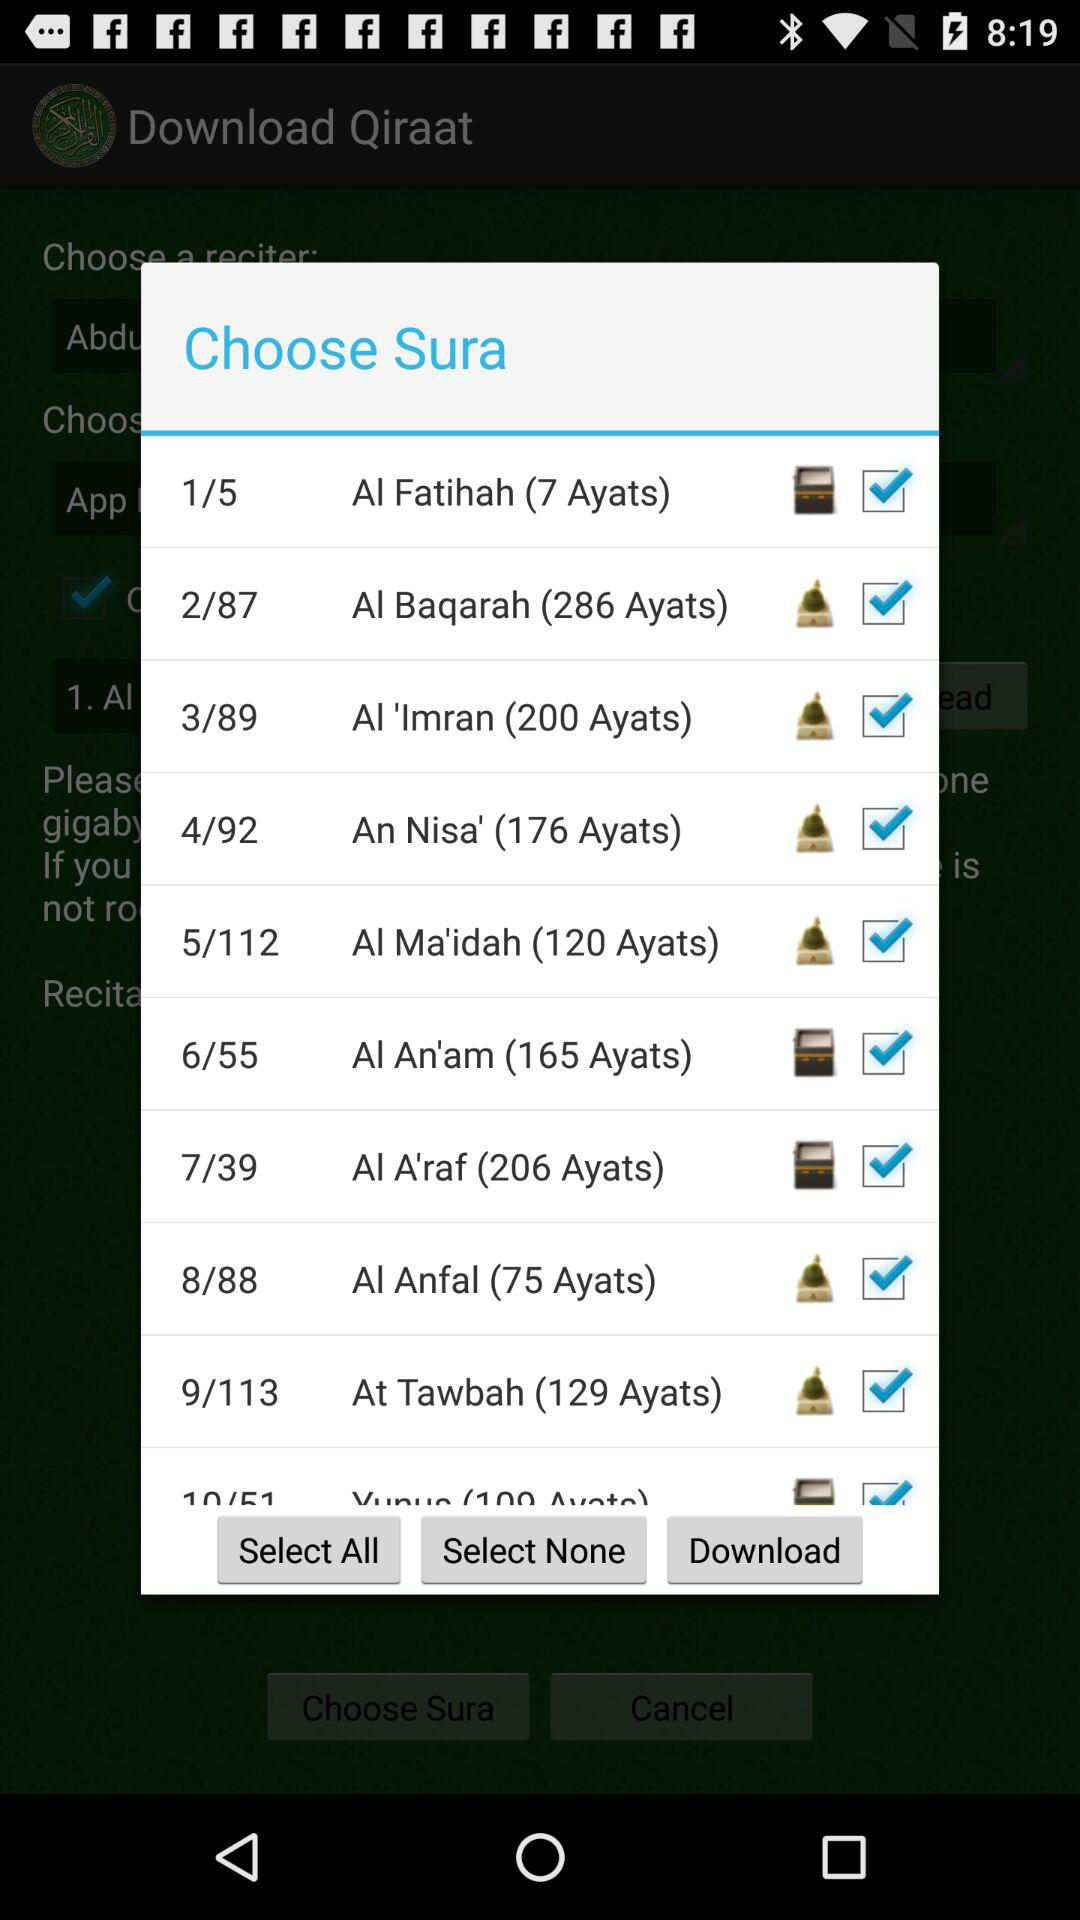Which sura is on 8/88?
Answer the question using a single word or phrase. Al Anfal is the sura on 8/88 